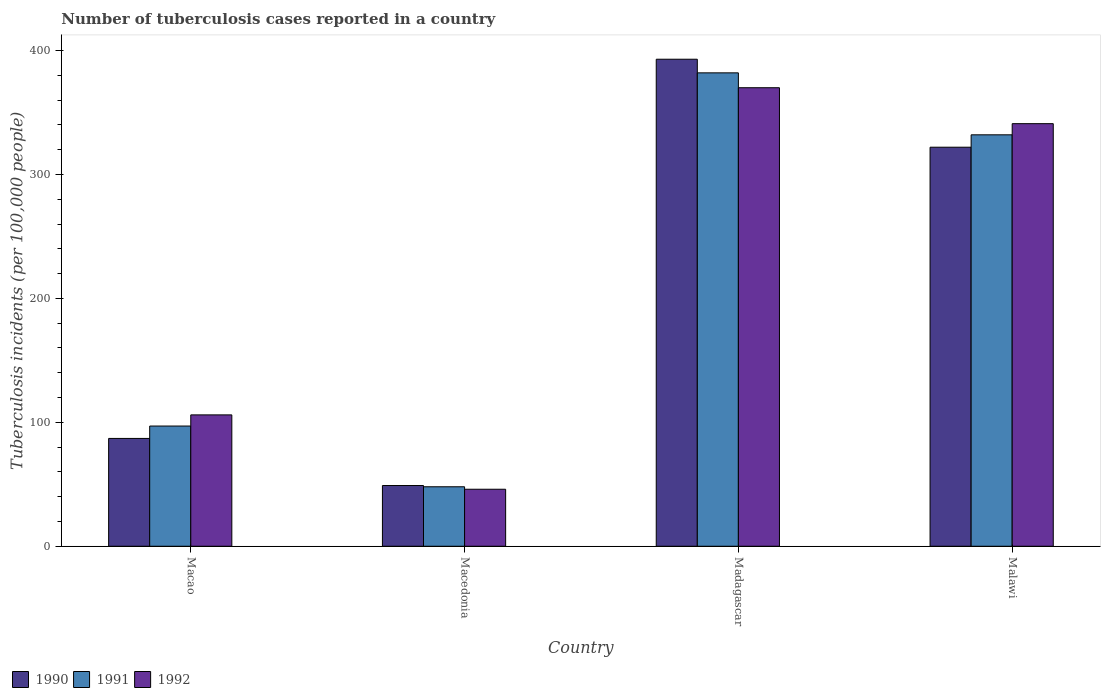How many groups of bars are there?
Keep it short and to the point. 4. Are the number of bars per tick equal to the number of legend labels?
Provide a short and direct response. Yes. Are the number of bars on each tick of the X-axis equal?
Offer a terse response. Yes. How many bars are there on the 2nd tick from the left?
Your response must be concise. 3. What is the label of the 3rd group of bars from the left?
Ensure brevity in your answer.  Madagascar. In how many cases, is the number of bars for a given country not equal to the number of legend labels?
Your answer should be compact. 0. What is the number of tuberculosis cases reported in in 1991 in Macedonia?
Make the answer very short. 48. Across all countries, what is the maximum number of tuberculosis cases reported in in 1991?
Provide a short and direct response. 382. In which country was the number of tuberculosis cases reported in in 1990 maximum?
Provide a short and direct response. Madagascar. In which country was the number of tuberculosis cases reported in in 1990 minimum?
Give a very brief answer. Macedonia. What is the total number of tuberculosis cases reported in in 1990 in the graph?
Provide a succinct answer. 851. What is the difference between the number of tuberculosis cases reported in in 1991 in Macao and that in Malawi?
Offer a very short reply. -235. What is the difference between the number of tuberculosis cases reported in in 1990 in Malawi and the number of tuberculosis cases reported in in 1991 in Macedonia?
Keep it short and to the point. 274. What is the average number of tuberculosis cases reported in in 1992 per country?
Give a very brief answer. 215.75. What is the difference between the number of tuberculosis cases reported in of/in 1991 and number of tuberculosis cases reported in of/in 1992 in Macao?
Make the answer very short. -9. In how many countries, is the number of tuberculosis cases reported in in 1992 greater than 240?
Make the answer very short. 2. What is the ratio of the number of tuberculosis cases reported in in 1992 in Macao to that in Macedonia?
Provide a succinct answer. 2.3. Is the number of tuberculosis cases reported in in 1992 in Macao less than that in Madagascar?
Keep it short and to the point. Yes. What is the difference between the highest and the lowest number of tuberculosis cases reported in in 1992?
Make the answer very short. 324. In how many countries, is the number of tuberculosis cases reported in in 1991 greater than the average number of tuberculosis cases reported in in 1991 taken over all countries?
Keep it short and to the point. 2. Is the sum of the number of tuberculosis cases reported in in 1992 in Macao and Macedonia greater than the maximum number of tuberculosis cases reported in in 1990 across all countries?
Your answer should be very brief. No. What does the 1st bar from the left in Macao represents?
Ensure brevity in your answer.  1990. Is it the case that in every country, the sum of the number of tuberculosis cases reported in in 1991 and number of tuberculosis cases reported in in 1990 is greater than the number of tuberculosis cases reported in in 1992?
Provide a short and direct response. Yes. Are all the bars in the graph horizontal?
Give a very brief answer. No. Are the values on the major ticks of Y-axis written in scientific E-notation?
Offer a very short reply. No. Does the graph contain any zero values?
Keep it short and to the point. No. Does the graph contain grids?
Make the answer very short. No. How many legend labels are there?
Make the answer very short. 3. How are the legend labels stacked?
Offer a terse response. Horizontal. What is the title of the graph?
Your answer should be very brief. Number of tuberculosis cases reported in a country. What is the label or title of the X-axis?
Your answer should be compact. Country. What is the label or title of the Y-axis?
Offer a very short reply. Tuberculosis incidents (per 100,0 people). What is the Tuberculosis incidents (per 100,000 people) in 1990 in Macao?
Your response must be concise. 87. What is the Tuberculosis incidents (per 100,000 people) in 1991 in Macao?
Make the answer very short. 97. What is the Tuberculosis incidents (per 100,000 people) of 1992 in Macao?
Give a very brief answer. 106. What is the Tuberculosis incidents (per 100,000 people) of 1992 in Macedonia?
Ensure brevity in your answer.  46. What is the Tuberculosis incidents (per 100,000 people) in 1990 in Madagascar?
Your response must be concise. 393. What is the Tuberculosis incidents (per 100,000 people) in 1991 in Madagascar?
Provide a short and direct response. 382. What is the Tuberculosis incidents (per 100,000 people) in 1992 in Madagascar?
Keep it short and to the point. 370. What is the Tuberculosis incidents (per 100,000 people) in 1990 in Malawi?
Offer a terse response. 322. What is the Tuberculosis incidents (per 100,000 people) in 1991 in Malawi?
Offer a very short reply. 332. What is the Tuberculosis incidents (per 100,000 people) of 1992 in Malawi?
Make the answer very short. 341. Across all countries, what is the maximum Tuberculosis incidents (per 100,000 people) of 1990?
Keep it short and to the point. 393. Across all countries, what is the maximum Tuberculosis incidents (per 100,000 people) of 1991?
Ensure brevity in your answer.  382. Across all countries, what is the maximum Tuberculosis incidents (per 100,000 people) of 1992?
Ensure brevity in your answer.  370. Across all countries, what is the minimum Tuberculosis incidents (per 100,000 people) in 1990?
Keep it short and to the point. 49. What is the total Tuberculosis incidents (per 100,000 people) in 1990 in the graph?
Offer a terse response. 851. What is the total Tuberculosis incidents (per 100,000 people) of 1991 in the graph?
Give a very brief answer. 859. What is the total Tuberculosis incidents (per 100,000 people) of 1992 in the graph?
Keep it short and to the point. 863. What is the difference between the Tuberculosis incidents (per 100,000 people) in 1991 in Macao and that in Macedonia?
Your answer should be compact. 49. What is the difference between the Tuberculosis incidents (per 100,000 people) in 1992 in Macao and that in Macedonia?
Make the answer very short. 60. What is the difference between the Tuberculosis incidents (per 100,000 people) in 1990 in Macao and that in Madagascar?
Ensure brevity in your answer.  -306. What is the difference between the Tuberculosis incidents (per 100,000 people) of 1991 in Macao and that in Madagascar?
Provide a short and direct response. -285. What is the difference between the Tuberculosis incidents (per 100,000 people) of 1992 in Macao and that in Madagascar?
Your response must be concise. -264. What is the difference between the Tuberculosis incidents (per 100,000 people) in 1990 in Macao and that in Malawi?
Your answer should be compact. -235. What is the difference between the Tuberculosis incidents (per 100,000 people) in 1991 in Macao and that in Malawi?
Keep it short and to the point. -235. What is the difference between the Tuberculosis incidents (per 100,000 people) in 1992 in Macao and that in Malawi?
Make the answer very short. -235. What is the difference between the Tuberculosis incidents (per 100,000 people) in 1990 in Macedonia and that in Madagascar?
Make the answer very short. -344. What is the difference between the Tuberculosis incidents (per 100,000 people) in 1991 in Macedonia and that in Madagascar?
Offer a very short reply. -334. What is the difference between the Tuberculosis incidents (per 100,000 people) of 1992 in Macedonia and that in Madagascar?
Offer a very short reply. -324. What is the difference between the Tuberculosis incidents (per 100,000 people) in 1990 in Macedonia and that in Malawi?
Your response must be concise. -273. What is the difference between the Tuberculosis incidents (per 100,000 people) of 1991 in Macedonia and that in Malawi?
Give a very brief answer. -284. What is the difference between the Tuberculosis incidents (per 100,000 people) in 1992 in Macedonia and that in Malawi?
Keep it short and to the point. -295. What is the difference between the Tuberculosis incidents (per 100,000 people) in 1992 in Madagascar and that in Malawi?
Ensure brevity in your answer.  29. What is the difference between the Tuberculosis incidents (per 100,000 people) in 1990 in Macao and the Tuberculosis incidents (per 100,000 people) in 1991 in Macedonia?
Offer a terse response. 39. What is the difference between the Tuberculosis incidents (per 100,000 people) of 1991 in Macao and the Tuberculosis incidents (per 100,000 people) of 1992 in Macedonia?
Offer a terse response. 51. What is the difference between the Tuberculosis incidents (per 100,000 people) in 1990 in Macao and the Tuberculosis incidents (per 100,000 people) in 1991 in Madagascar?
Offer a very short reply. -295. What is the difference between the Tuberculosis incidents (per 100,000 people) in 1990 in Macao and the Tuberculosis incidents (per 100,000 people) in 1992 in Madagascar?
Keep it short and to the point. -283. What is the difference between the Tuberculosis incidents (per 100,000 people) of 1991 in Macao and the Tuberculosis incidents (per 100,000 people) of 1992 in Madagascar?
Provide a short and direct response. -273. What is the difference between the Tuberculosis incidents (per 100,000 people) in 1990 in Macao and the Tuberculosis incidents (per 100,000 people) in 1991 in Malawi?
Give a very brief answer. -245. What is the difference between the Tuberculosis incidents (per 100,000 people) of 1990 in Macao and the Tuberculosis incidents (per 100,000 people) of 1992 in Malawi?
Offer a terse response. -254. What is the difference between the Tuberculosis incidents (per 100,000 people) in 1991 in Macao and the Tuberculosis incidents (per 100,000 people) in 1992 in Malawi?
Give a very brief answer. -244. What is the difference between the Tuberculosis incidents (per 100,000 people) of 1990 in Macedonia and the Tuberculosis incidents (per 100,000 people) of 1991 in Madagascar?
Your answer should be very brief. -333. What is the difference between the Tuberculosis incidents (per 100,000 people) of 1990 in Macedonia and the Tuberculosis incidents (per 100,000 people) of 1992 in Madagascar?
Your answer should be compact. -321. What is the difference between the Tuberculosis incidents (per 100,000 people) of 1991 in Macedonia and the Tuberculosis incidents (per 100,000 people) of 1992 in Madagascar?
Provide a succinct answer. -322. What is the difference between the Tuberculosis incidents (per 100,000 people) in 1990 in Macedonia and the Tuberculosis incidents (per 100,000 people) in 1991 in Malawi?
Provide a short and direct response. -283. What is the difference between the Tuberculosis incidents (per 100,000 people) in 1990 in Macedonia and the Tuberculosis incidents (per 100,000 people) in 1992 in Malawi?
Make the answer very short. -292. What is the difference between the Tuberculosis incidents (per 100,000 people) in 1991 in Macedonia and the Tuberculosis incidents (per 100,000 people) in 1992 in Malawi?
Keep it short and to the point. -293. What is the difference between the Tuberculosis incidents (per 100,000 people) in 1990 in Madagascar and the Tuberculosis incidents (per 100,000 people) in 1991 in Malawi?
Give a very brief answer. 61. What is the difference between the Tuberculosis incidents (per 100,000 people) of 1990 in Madagascar and the Tuberculosis incidents (per 100,000 people) of 1992 in Malawi?
Keep it short and to the point. 52. What is the average Tuberculosis incidents (per 100,000 people) of 1990 per country?
Offer a very short reply. 212.75. What is the average Tuberculosis incidents (per 100,000 people) in 1991 per country?
Provide a short and direct response. 214.75. What is the average Tuberculosis incidents (per 100,000 people) in 1992 per country?
Provide a succinct answer. 215.75. What is the difference between the Tuberculosis incidents (per 100,000 people) in 1990 and Tuberculosis incidents (per 100,000 people) in 1992 in Macao?
Provide a short and direct response. -19. What is the difference between the Tuberculosis incidents (per 100,000 people) in 1991 and Tuberculosis incidents (per 100,000 people) in 1992 in Macao?
Keep it short and to the point. -9. What is the difference between the Tuberculosis incidents (per 100,000 people) in 1990 and Tuberculosis incidents (per 100,000 people) in 1992 in Macedonia?
Give a very brief answer. 3. What is the difference between the Tuberculosis incidents (per 100,000 people) in 1991 and Tuberculosis incidents (per 100,000 people) in 1992 in Macedonia?
Ensure brevity in your answer.  2. What is the difference between the Tuberculosis incidents (per 100,000 people) in 1990 and Tuberculosis incidents (per 100,000 people) in 1992 in Madagascar?
Provide a short and direct response. 23. What is the difference between the Tuberculosis incidents (per 100,000 people) in 1991 and Tuberculosis incidents (per 100,000 people) in 1992 in Madagascar?
Provide a succinct answer. 12. What is the difference between the Tuberculosis incidents (per 100,000 people) of 1990 and Tuberculosis incidents (per 100,000 people) of 1991 in Malawi?
Your answer should be very brief. -10. What is the difference between the Tuberculosis incidents (per 100,000 people) of 1990 and Tuberculosis incidents (per 100,000 people) of 1992 in Malawi?
Offer a very short reply. -19. What is the difference between the Tuberculosis incidents (per 100,000 people) of 1991 and Tuberculosis incidents (per 100,000 people) of 1992 in Malawi?
Your answer should be compact. -9. What is the ratio of the Tuberculosis incidents (per 100,000 people) of 1990 in Macao to that in Macedonia?
Make the answer very short. 1.78. What is the ratio of the Tuberculosis incidents (per 100,000 people) in 1991 in Macao to that in Macedonia?
Provide a short and direct response. 2.02. What is the ratio of the Tuberculosis incidents (per 100,000 people) in 1992 in Macao to that in Macedonia?
Make the answer very short. 2.3. What is the ratio of the Tuberculosis incidents (per 100,000 people) in 1990 in Macao to that in Madagascar?
Offer a terse response. 0.22. What is the ratio of the Tuberculosis incidents (per 100,000 people) of 1991 in Macao to that in Madagascar?
Provide a short and direct response. 0.25. What is the ratio of the Tuberculosis incidents (per 100,000 people) of 1992 in Macao to that in Madagascar?
Offer a very short reply. 0.29. What is the ratio of the Tuberculosis incidents (per 100,000 people) of 1990 in Macao to that in Malawi?
Offer a terse response. 0.27. What is the ratio of the Tuberculosis incidents (per 100,000 people) of 1991 in Macao to that in Malawi?
Provide a short and direct response. 0.29. What is the ratio of the Tuberculosis incidents (per 100,000 people) of 1992 in Macao to that in Malawi?
Make the answer very short. 0.31. What is the ratio of the Tuberculosis incidents (per 100,000 people) of 1990 in Macedonia to that in Madagascar?
Offer a terse response. 0.12. What is the ratio of the Tuberculosis incidents (per 100,000 people) of 1991 in Macedonia to that in Madagascar?
Offer a very short reply. 0.13. What is the ratio of the Tuberculosis incidents (per 100,000 people) in 1992 in Macedonia to that in Madagascar?
Provide a short and direct response. 0.12. What is the ratio of the Tuberculosis incidents (per 100,000 people) in 1990 in Macedonia to that in Malawi?
Provide a short and direct response. 0.15. What is the ratio of the Tuberculosis incidents (per 100,000 people) in 1991 in Macedonia to that in Malawi?
Your answer should be compact. 0.14. What is the ratio of the Tuberculosis incidents (per 100,000 people) in 1992 in Macedonia to that in Malawi?
Ensure brevity in your answer.  0.13. What is the ratio of the Tuberculosis incidents (per 100,000 people) in 1990 in Madagascar to that in Malawi?
Offer a terse response. 1.22. What is the ratio of the Tuberculosis incidents (per 100,000 people) of 1991 in Madagascar to that in Malawi?
Give a very brief answer. 1.15. What is the ratio of the Tuberculosis incidents (per 100,000 people) of 1992 in Madagascar to that in Malawi?
Make the answer very short. 1.08. What is the difference between the highest and the second highest Tuberculosis incidents (per 100,000 people) in 1992?
Offer a terse response. 29. What is the difference between the highest and the lowest Tuberculosis incidents (per 100,000 people) in 1990?
Your answer should be compact. 344. What is the difference between the highest and the lowest Tuberculosis incidents (per 100,000 people) in 1991?
Your answer should be compact. 334. What is the difference between the highest and the lowest Tuberculosis incidents (per 100,000 people) of 1992?
Ensure brevity in your answer.  324. 